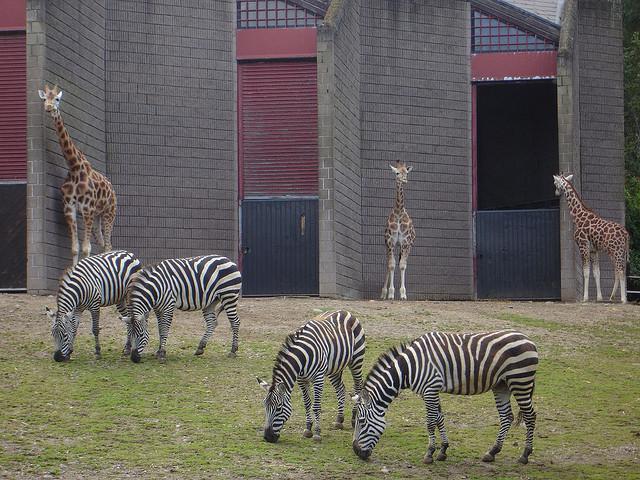How many types of animals are there?
Give a very brief answer. 2. How many creatures are in the photo?
Give a very brief answer. 7. How many zebras?
Give a very brief answer. 4. How many species of animals are there?
Give a very brief answer. 2. How many zebras are there?
Give a very brief answer. 4. How many giraffes can be seen?
Give a very brief answer. 3. 